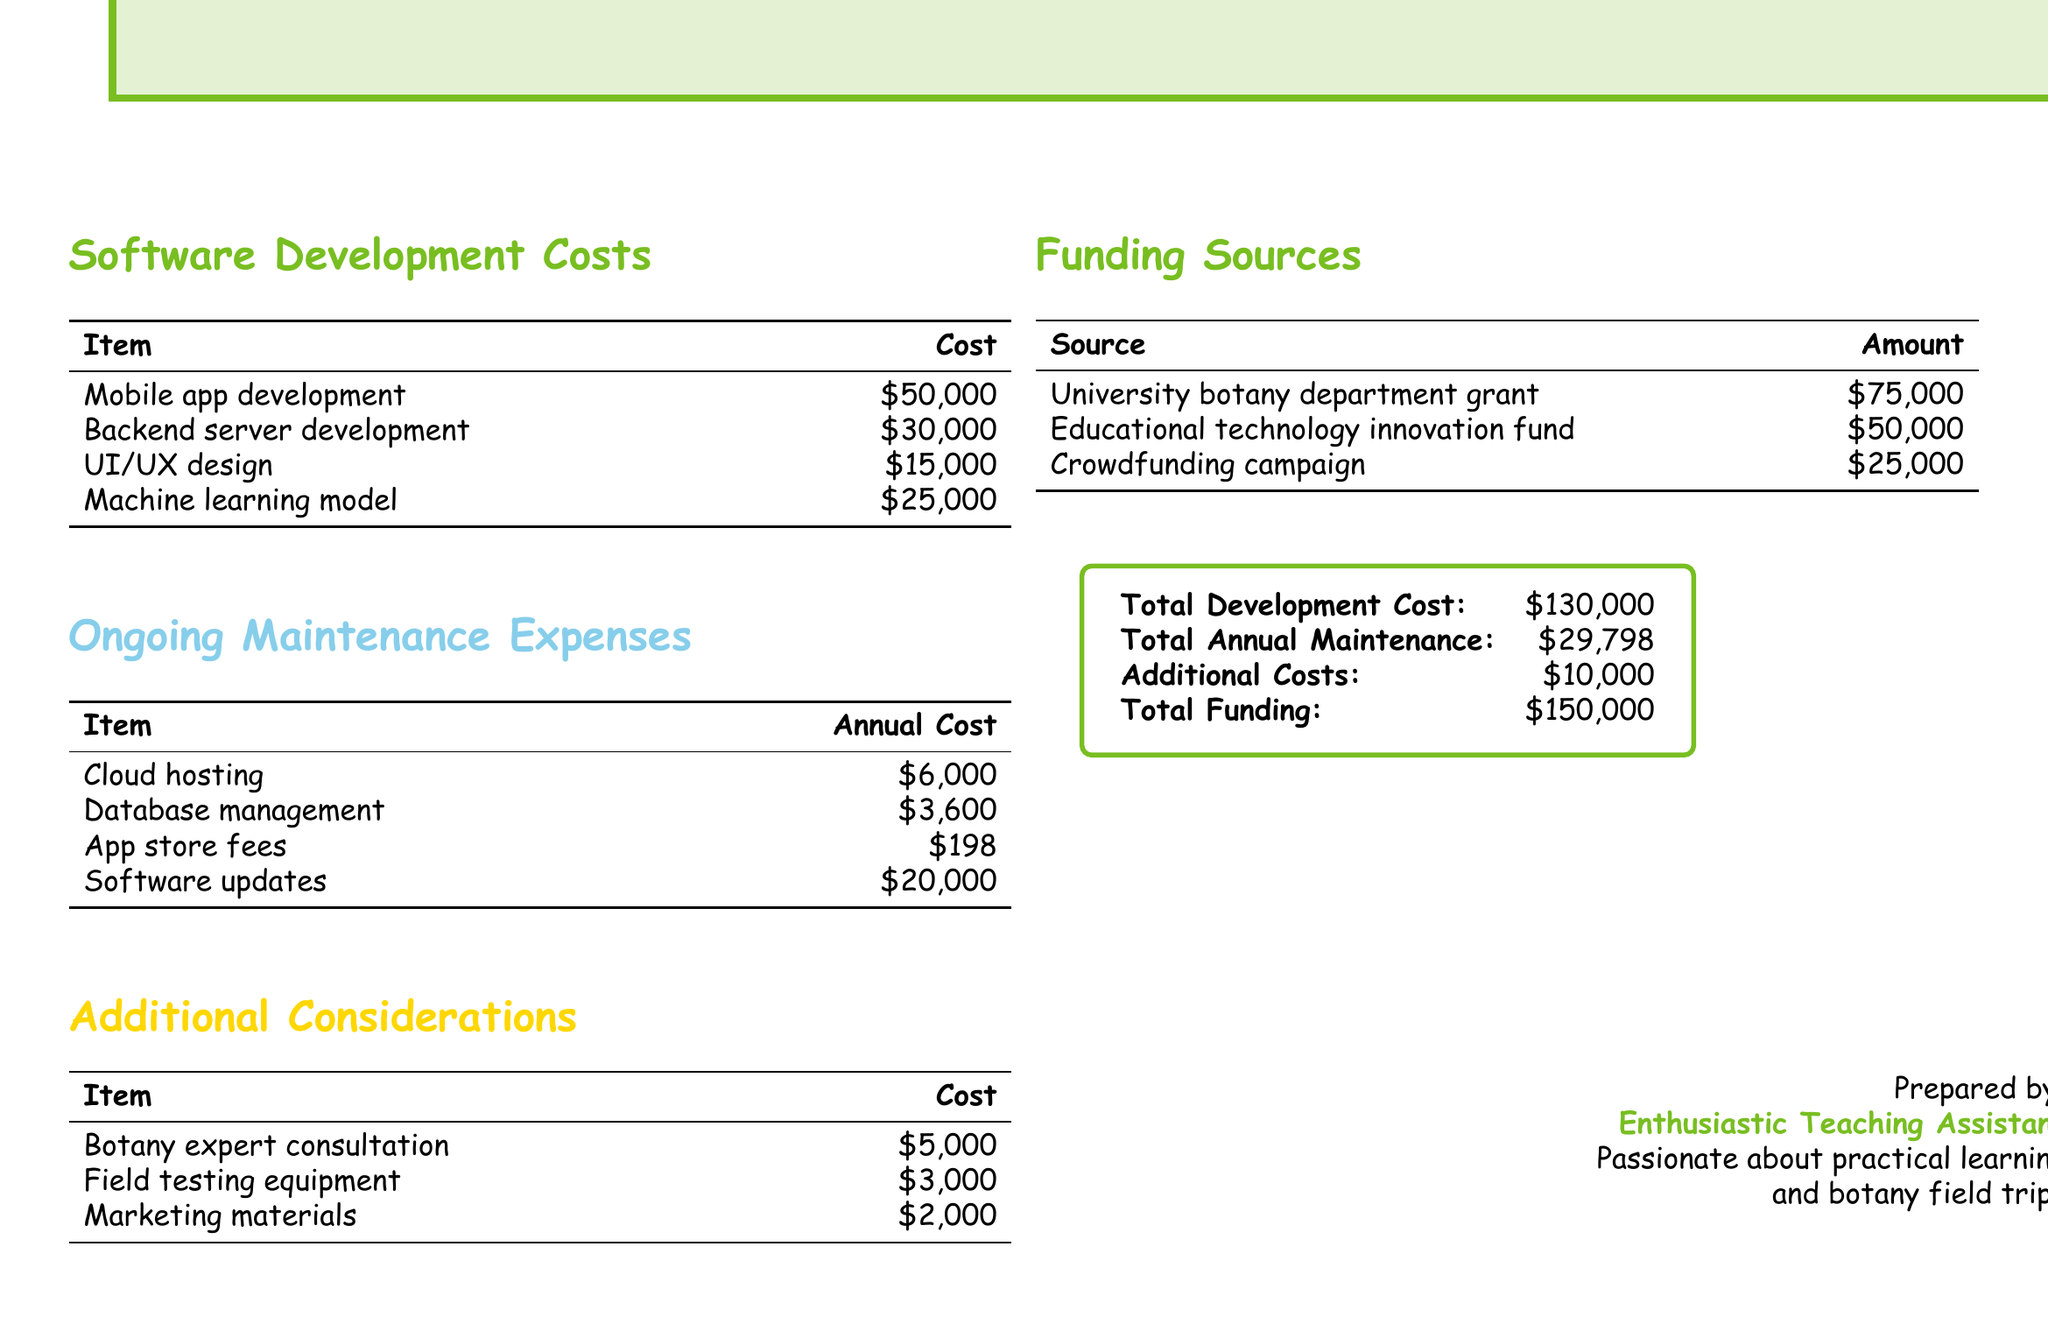what is the total development cost? The total development cost is stated in the document as $130,000.
Answer: $130,000 what is the cost of the mobile app development? The mobile app development cost listed in the document is $50,000.
Answer: $50,000 how much are the app store fees? The document lists app store fees as $198 annually.
Answer: $198 what is the total annual maintenance cost? The total annual maintenance cost shown in the document is $29,798.
Answer: $29,798 what is the amount of the university botany department grant? The university botany department grant is mentioned as $75,000 in the document.
Answer: $75,000 how much does the machine learning model cost? The machine learning model cost in the document is $25,000.
Answer: $25,000 what is the total funding amount? The total funding amount stated in the document is $150,000.
Answer: $150,000 what are the additional costs listed in the document? The additional costs mentioned total $10,000 in the document.
Answer: $10,000 how much is allocated for software updates annually? The annual cost for software updates is listed as $20,000 in the document.
Answer: $20,000 